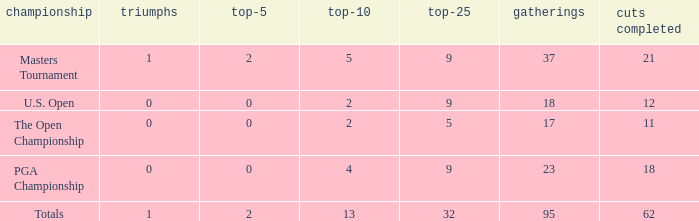I'm looking to parse the entire table for insights. Could you assist me with that? {'header': ['championship', 'triumphs', 'top-5', 'top-10', 'top-25', 'gatherings', 'cuts completed'], 'rows': [['Masters Tournament', '1', '2', '5', '9', '37', '21'], ['U.S. Open', '0', '0', '2', '9', '18', '12'], ['The Open Championship', '0', '0', '2', '5', '17', '11'], ['PGA Championship', '0', '0', '4', '9', '23', '18'], ['Totals', '1', '2', '13', '32', '95', '62']]} What is the number of wins that is in the top 10 and larger than 13? None. 